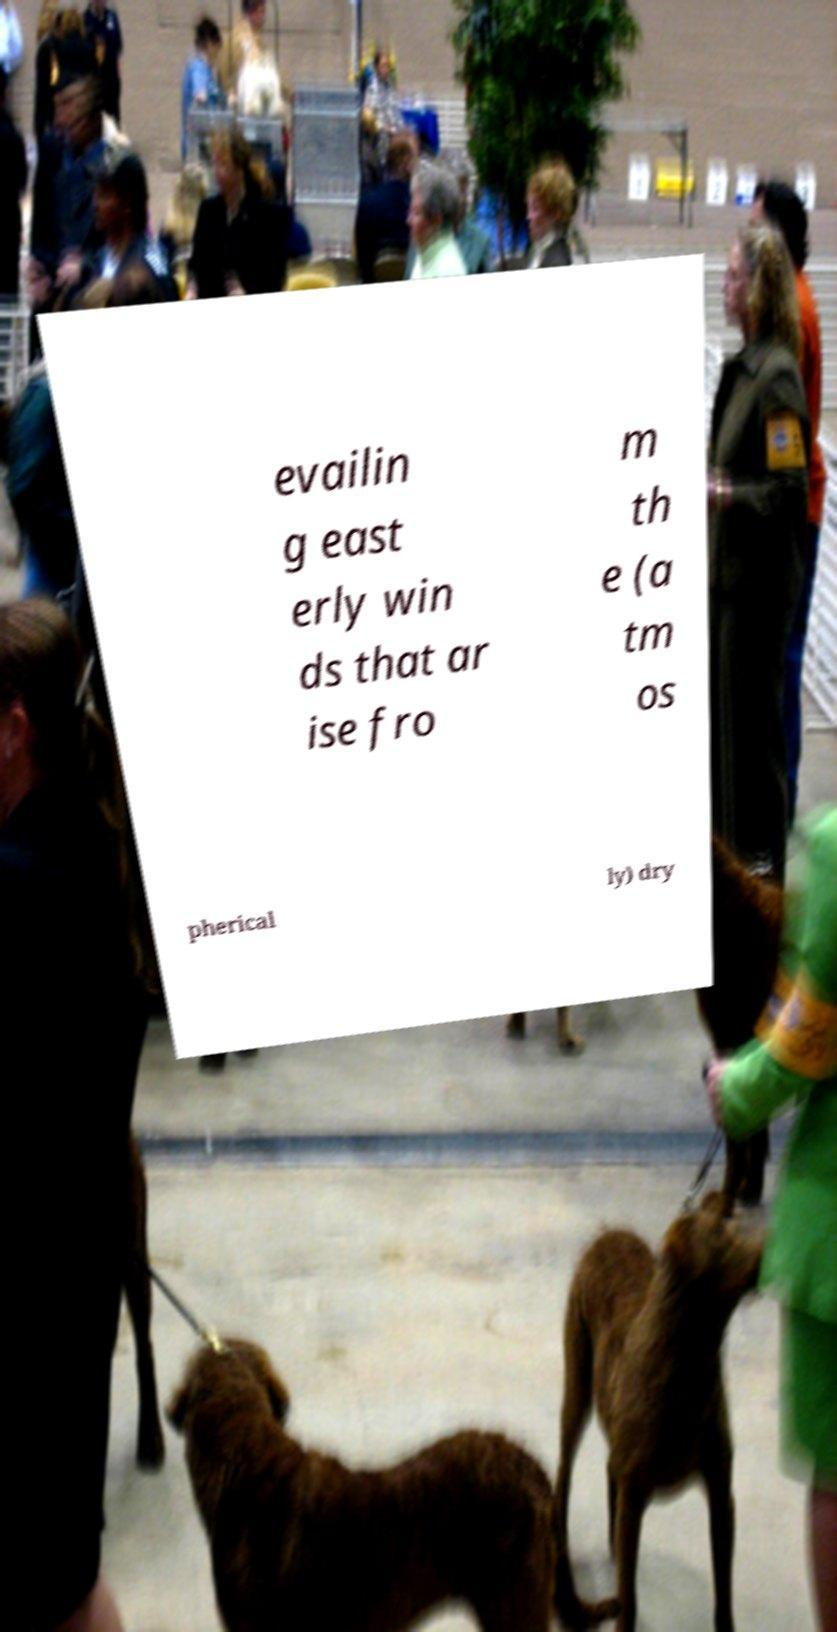I need the written content from this picture converted into text. Can you do that? evailin g east erly win ds that ar ise fro m th e (a tm os pherical ly) dry 